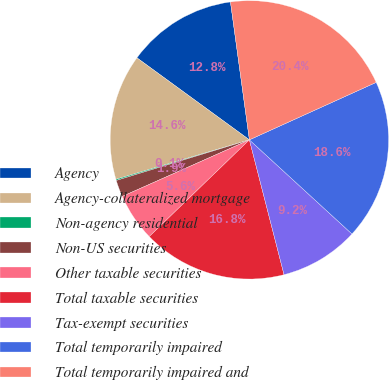Convert chart to OTSL. <chart><loc_0><loc_0><loc_500><loc_500><pie_chart><fcel>Agency<fcel>Agency-collateralized mortgage<fcel>Non-agency residential<fcel>Non-US securities<fcel>Other taxable securities<fcel>Total taxable securities<fcel>Tax-exempt securities<fcel>Total temporarily impaired<fcel>Total temporarily impaired and<nl><fcel>12.8%<fcel>14.6%<fcel>0.14%<fcel>1.95%<fcel>5.56%<fcel>16.78%<fcel>9.18%<fcel>18.59%<fcel>20.4%<nl></chart> 